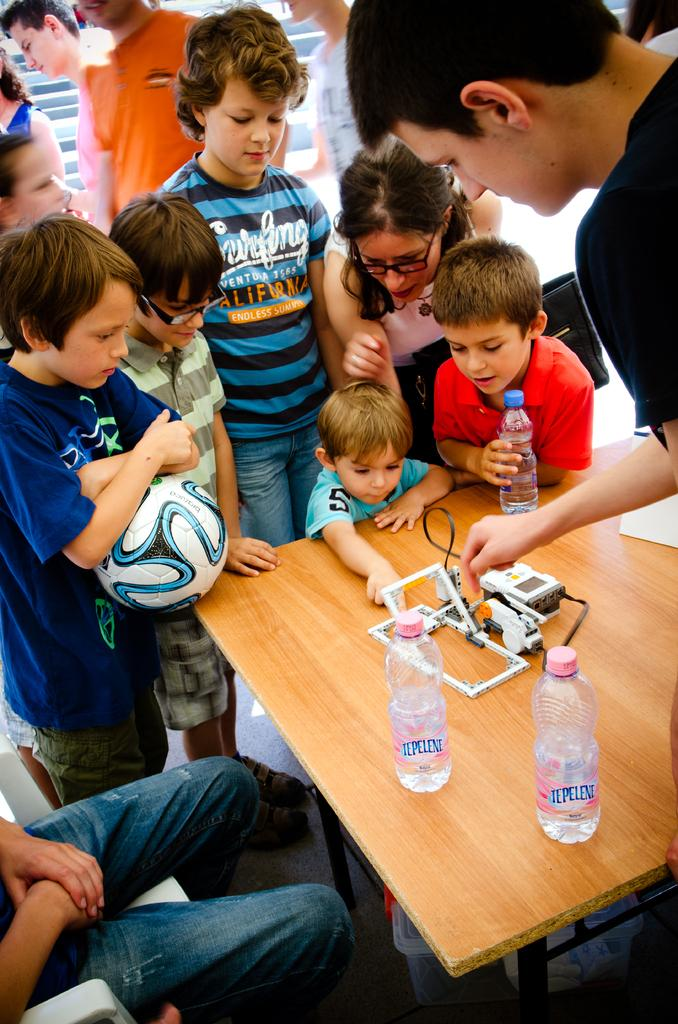How many people are in the image? There are persons in the image. What is present in the image besides the people? There is a table in the image. What can be seen on the table? There are bottles on the table. What is the position of one of the persons in the image? There is a person sitting on a chair in the image. Can you see the father giving a kiss to the cabbage in the image? There is no father or cabbage present in the image, and therefore no such interaction can be observed. 